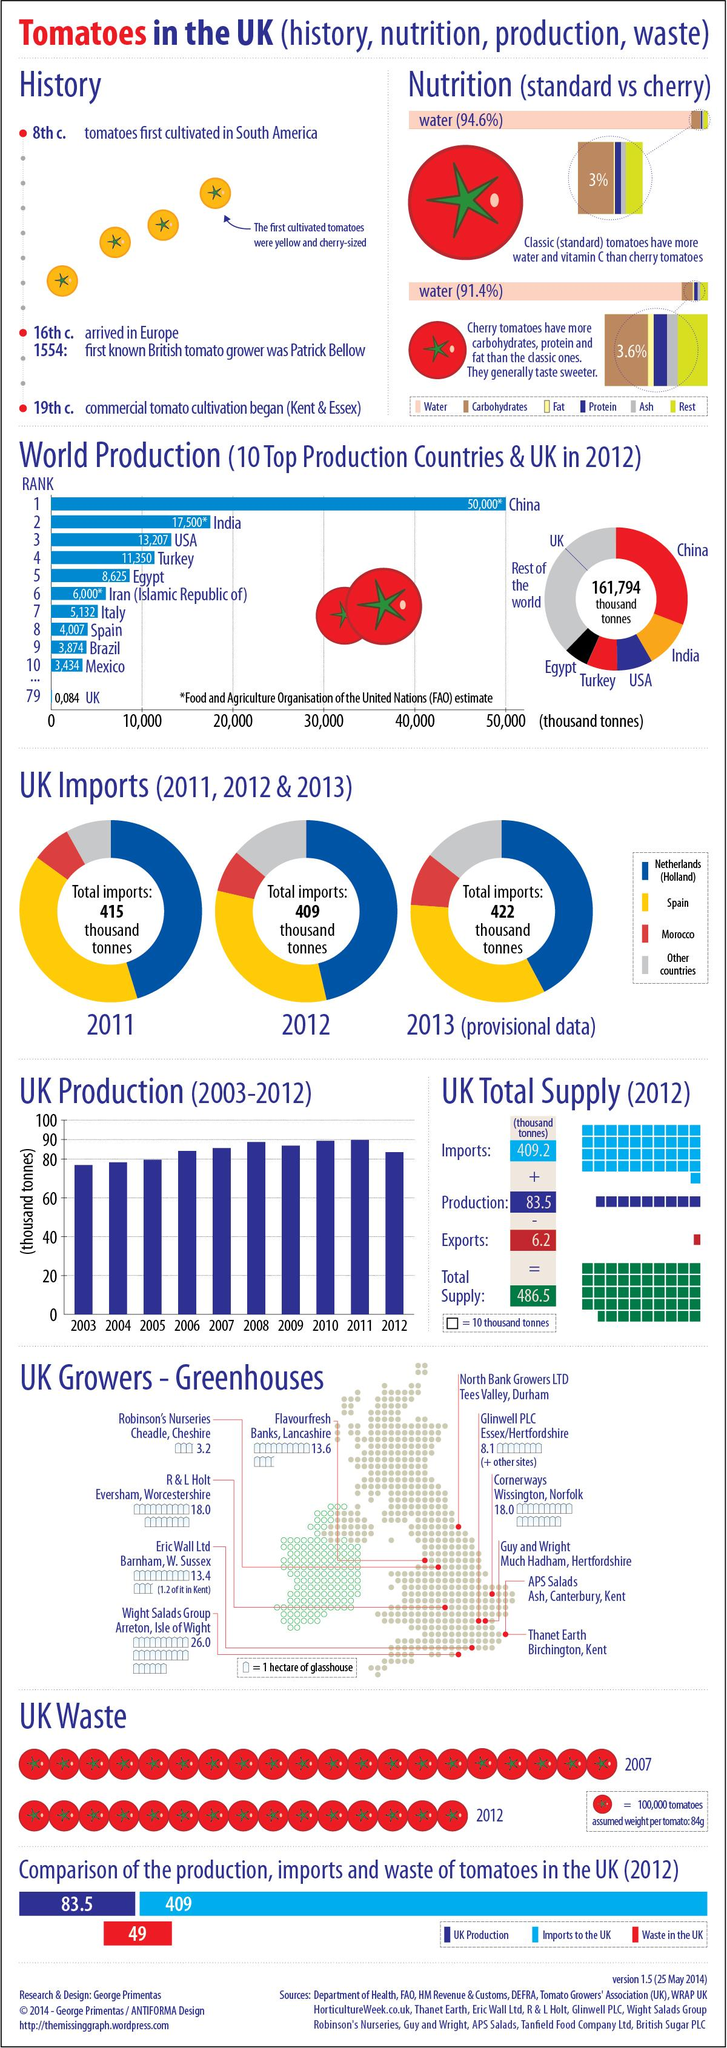List a handful of essential elements in this visual. In 2012, approximately 49 thousand tonnes of tomatoes were wasted in the United Kingdom. Classic tomatoes contain approximately 94.6% water by weight. The cherry tomatoes are known for their sweet taste compared to other types of tomatoes. According to the Food and Agriculture Organization of the United Nations, China was the largest producer of tomatoes in 2012. According to the FAO of the United Nations, an estimated 5,132 thousand tonnes of tomatoes were produced in Italy in 2012. 